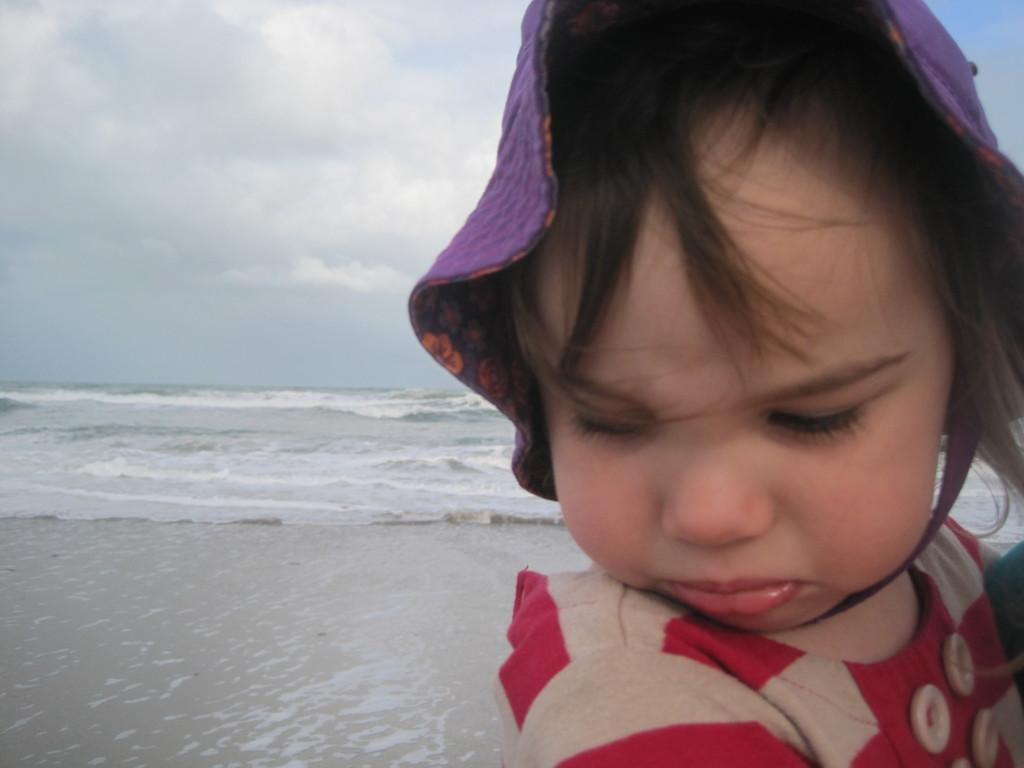What is the main subject of the image? The main subject of the image is a kid. Where is the kid located in the image? The kid is on the seashore. What is the condition of the sky in the image? The sky is clouded in the image. What type of approval does the kid need to build a sandcastle in the image? There is no indication in the image that the kid is building a sandcastle or needs any approval to do so. 